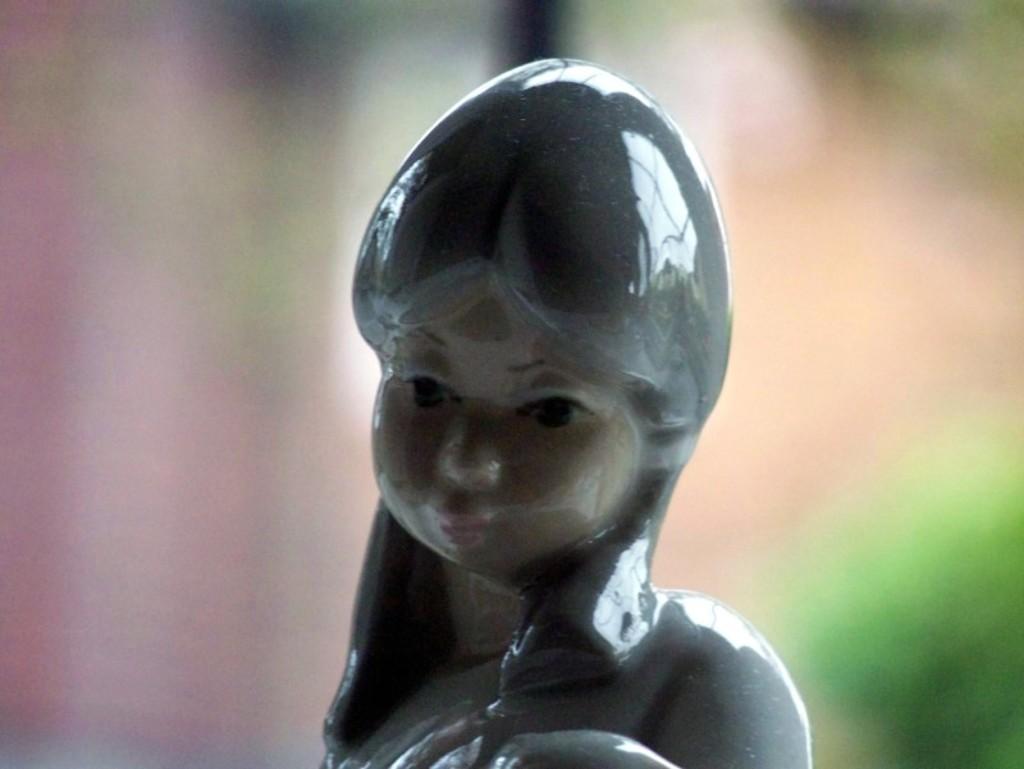Please provide a concise description of this image. In this image, this looks like a ceramic sculpture of the woman. The background looks blurry. 